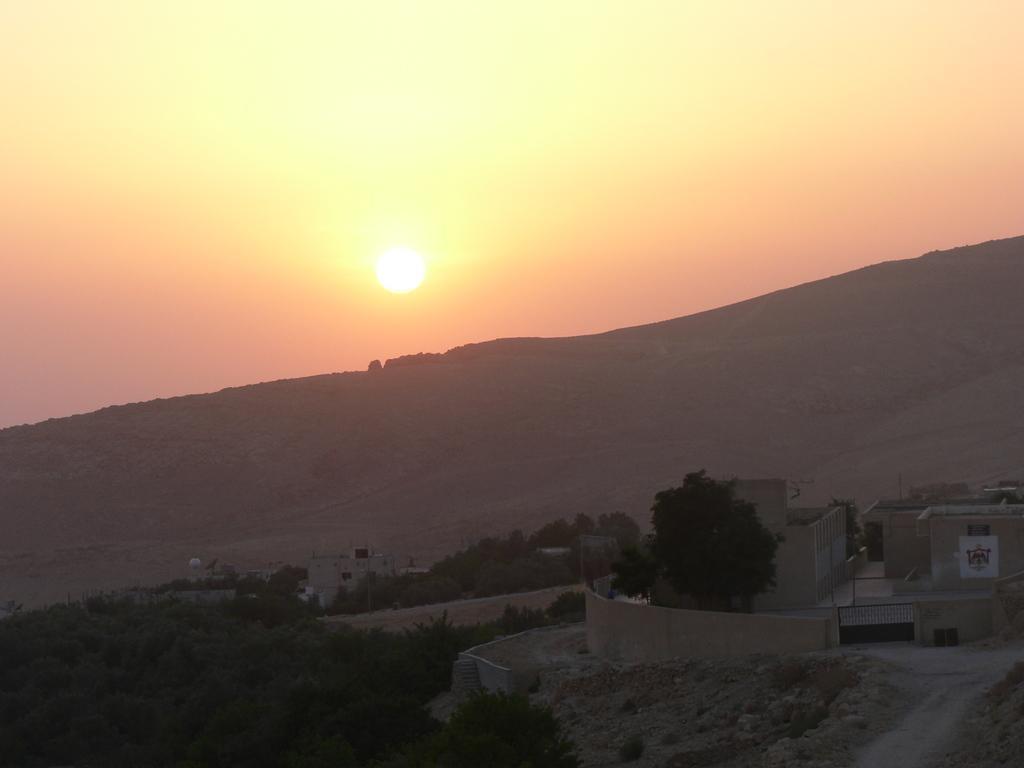What type of structures can be seen in the image? There are houses in the image. What other natural elements are present in the image? There are plants, trees, and a mountain visible in the image. What can be seen in the background of the image? The sun and the sky are visible in the background of the image. What type of canvas is being used to paint the houses in the image? There is no canvas present in the image, as it is a photograph or a digital representation of the scene. Can you see the toes of the people living in the houses in the image? There are no people visible in the image, so it is not possible to see their toes. 